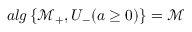Convert formula to latex. <formula><loc_0><loc_0><loc_500><loc_500>a l g \left \{ \mathcal { M } _ { + } , U _ { - } ( a \geq 0 ) \right \} = \mathcal { M }</formula> 